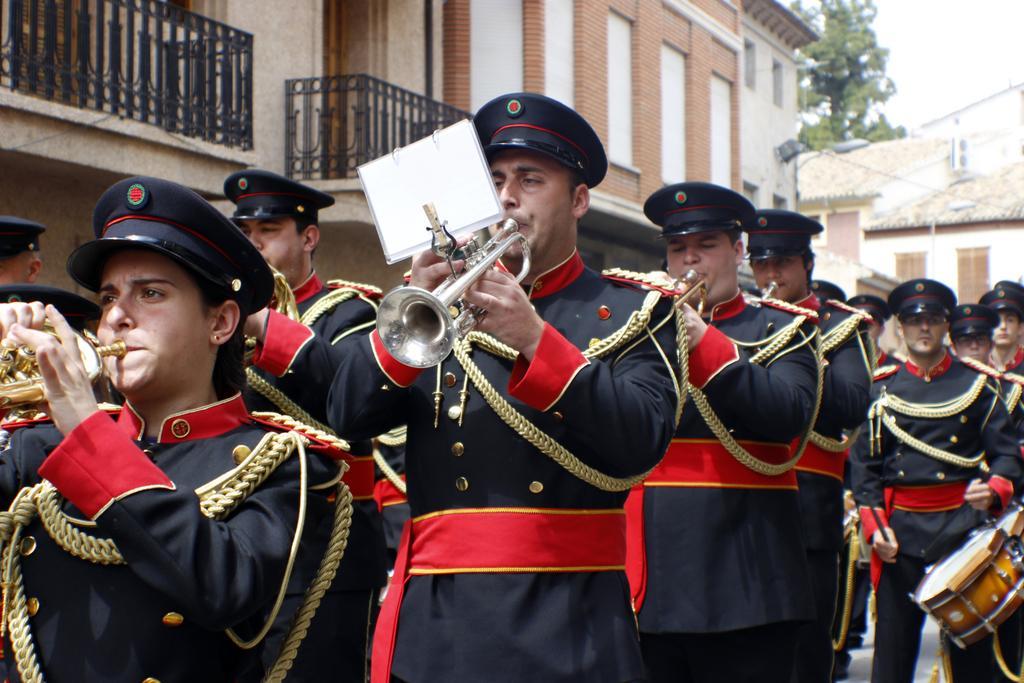In one or two sentences, can you explain what this image depicts? In this picture we can see a group of people wore caps and playing drums and trumpets with their hands, buildings, paper and in the background we can see trees. 